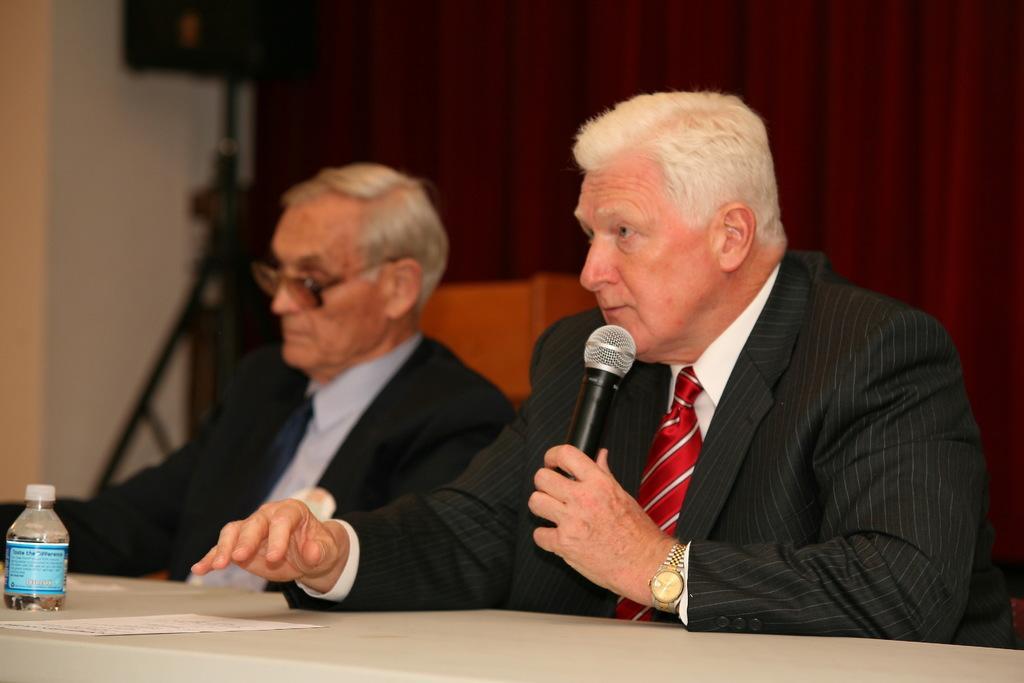Please provide a concise description of this image. Here we can see two people. These people wore suits. This man is holding a mic. On this table there is a paper and bottle. Background it is blur. We can see a red curtain, wall and speaker stand.   